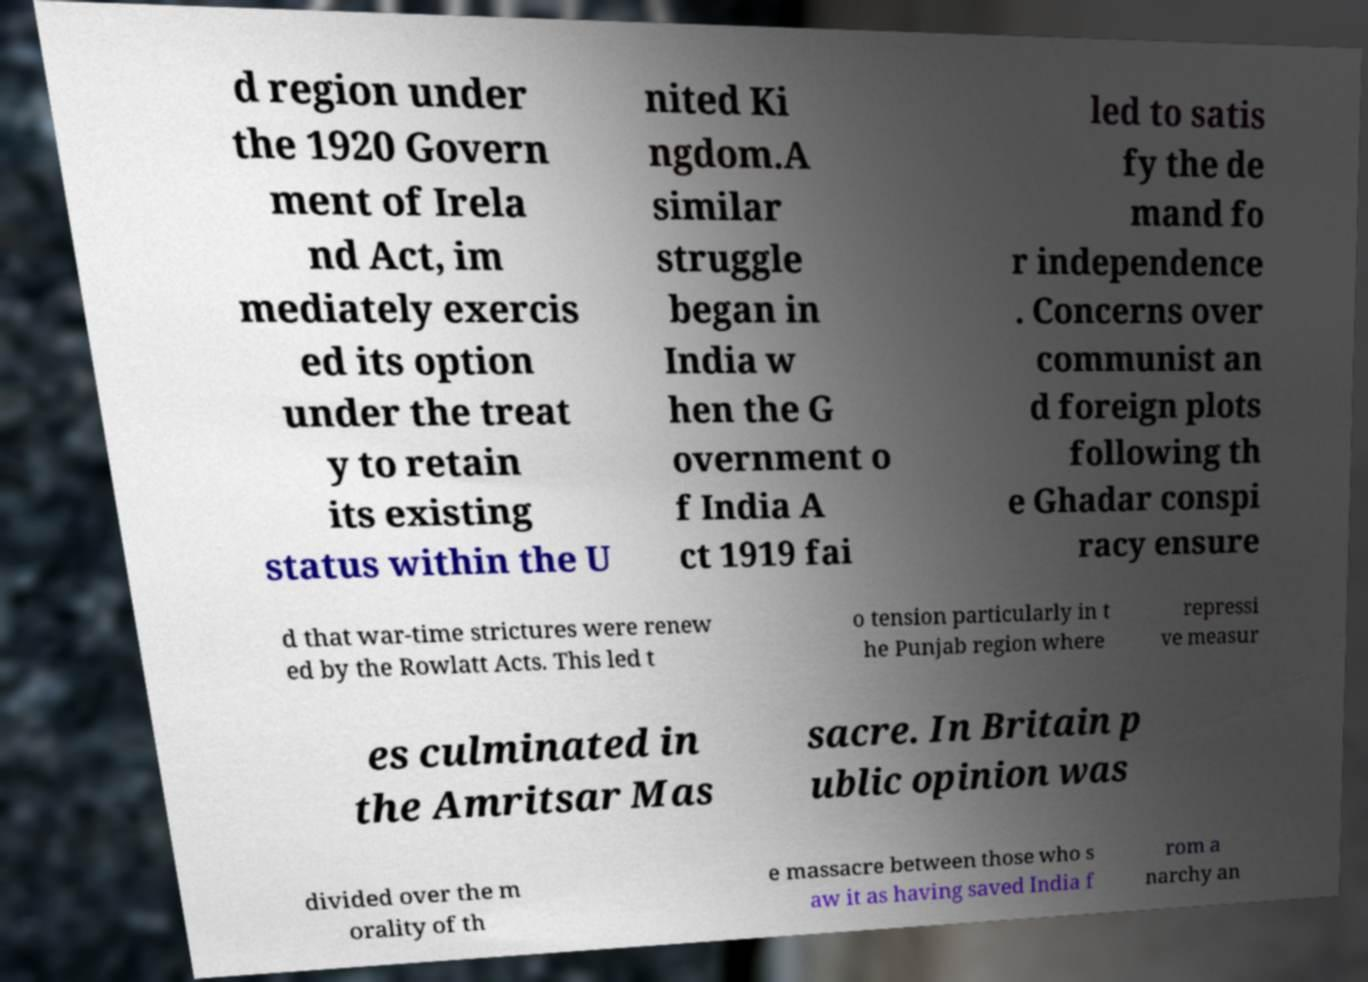Please read and relay the text visible in this image. What does it say? d region under the 1920 Govern ment of Irela nd Act, im mediately exercis ed its option under the treat y to retain its existing status within the U nited Ki ngdom.A similar struggle began in India w hen the G overnment o f India A ct 1919 fai led to satis fy the de mand fo r independence . Concerns over communist an d foreign plots following th e Ghadar conspi racy ensure d that war-time strictures were renew ed by the Rowlatt Acts. This led t o tension particularly in t he Punjab region where repressi ve measur es culminated in the Amritsar Mas sacre. In Britain p ublic opinion was divided over the m orality of th e massacre between those who s aw it as having saved India f rom a narchy an 